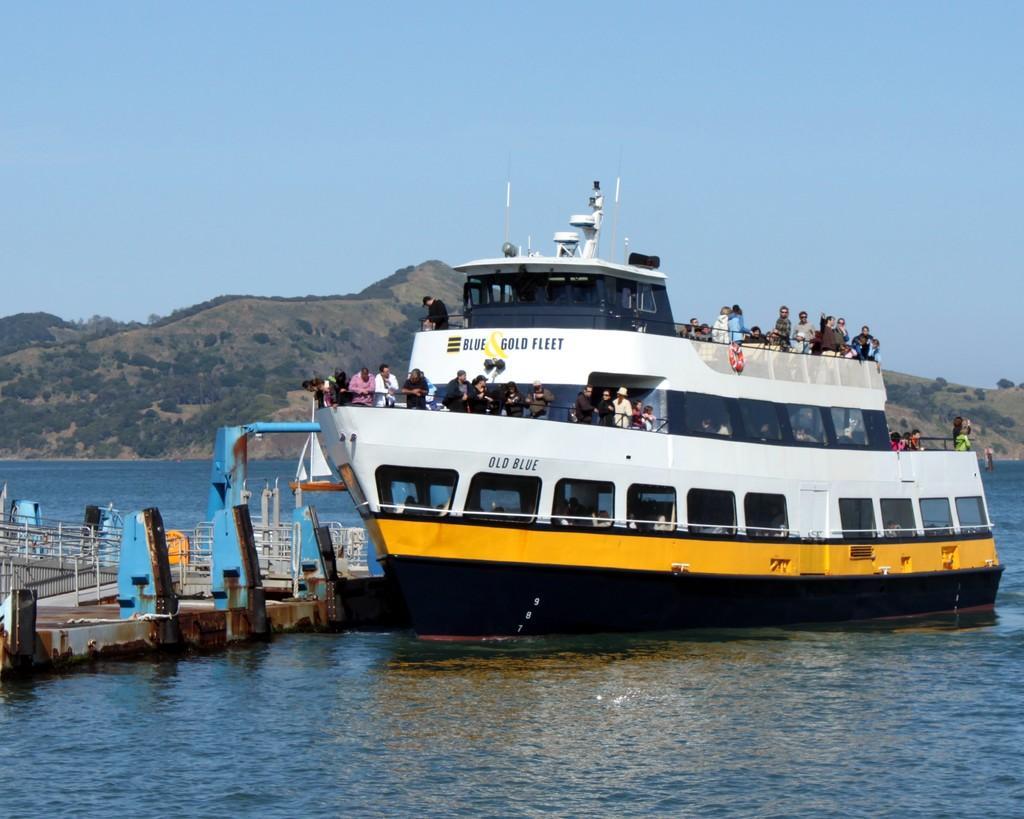Please provide a concise description of this image. This image consists of a ship in which there are many people. The ship is in white and yellow color. At the bottom, there is water. In the background, there are mountains. 